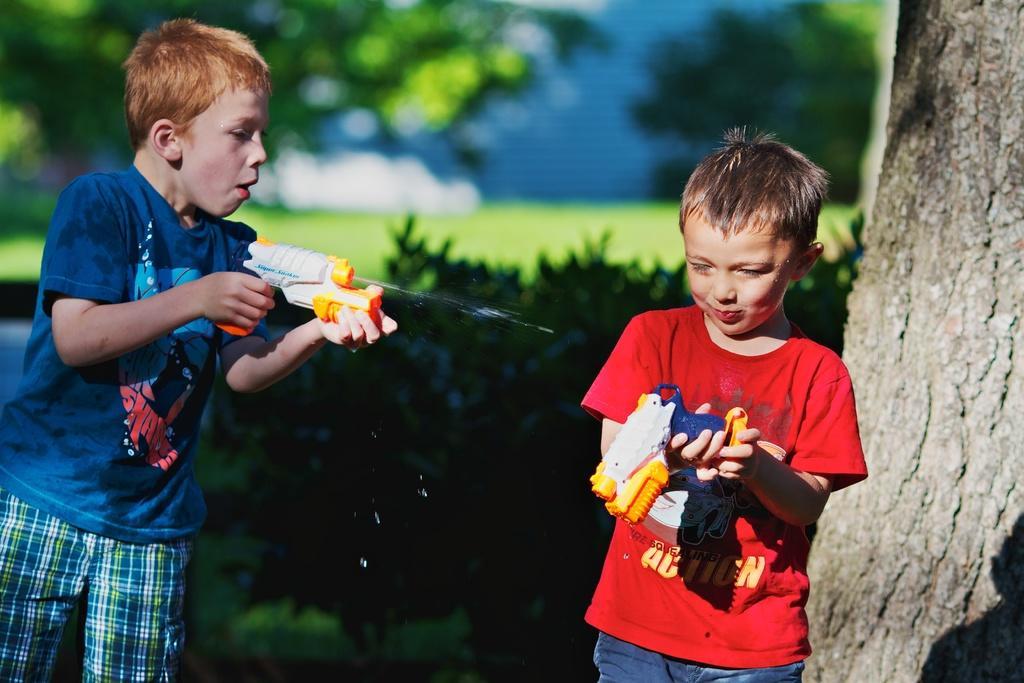Describe this image in one or two sentences. In this image we can see boys standing on the ground and holding toys in their hands. In the background there are trees and bushes. 